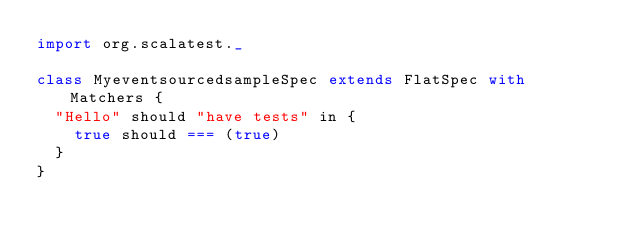Convert code to text. <code><loc_0><loc_0><loc_500><loc_500><_Scala_>import org.scalatest._

class MyeventsourcedsampleSpec extends FlatSpec with Matchers {
  "Hello" should "have tests" in {
    true should === (true)
  }
}
</code> 